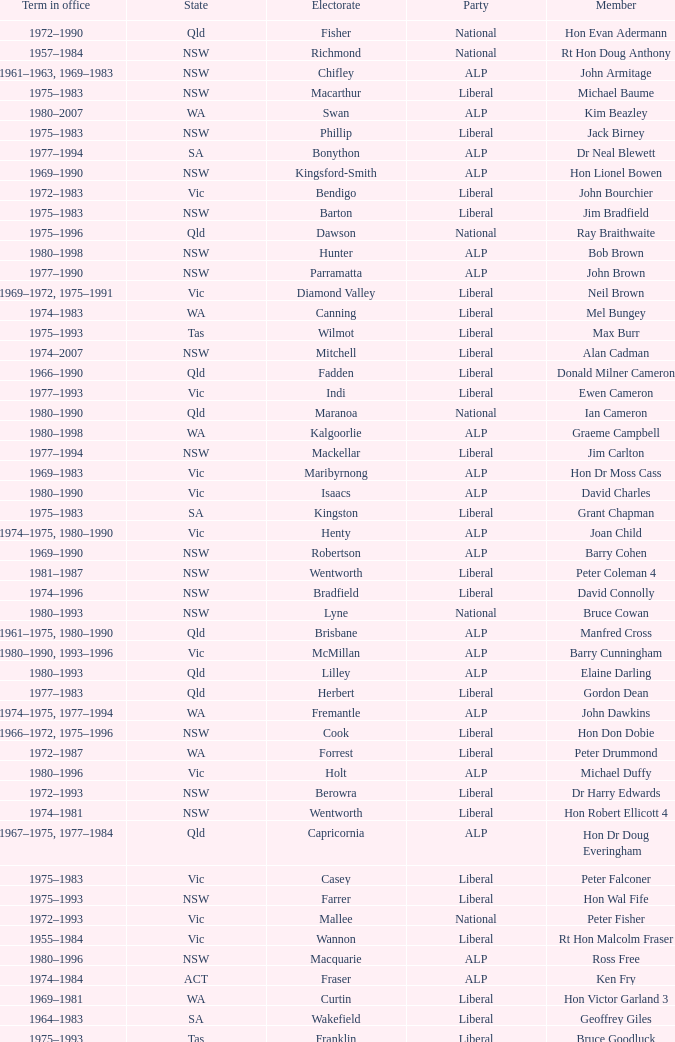When was Hon Les Johnson in office? 1955–1966, 1969–1984. 